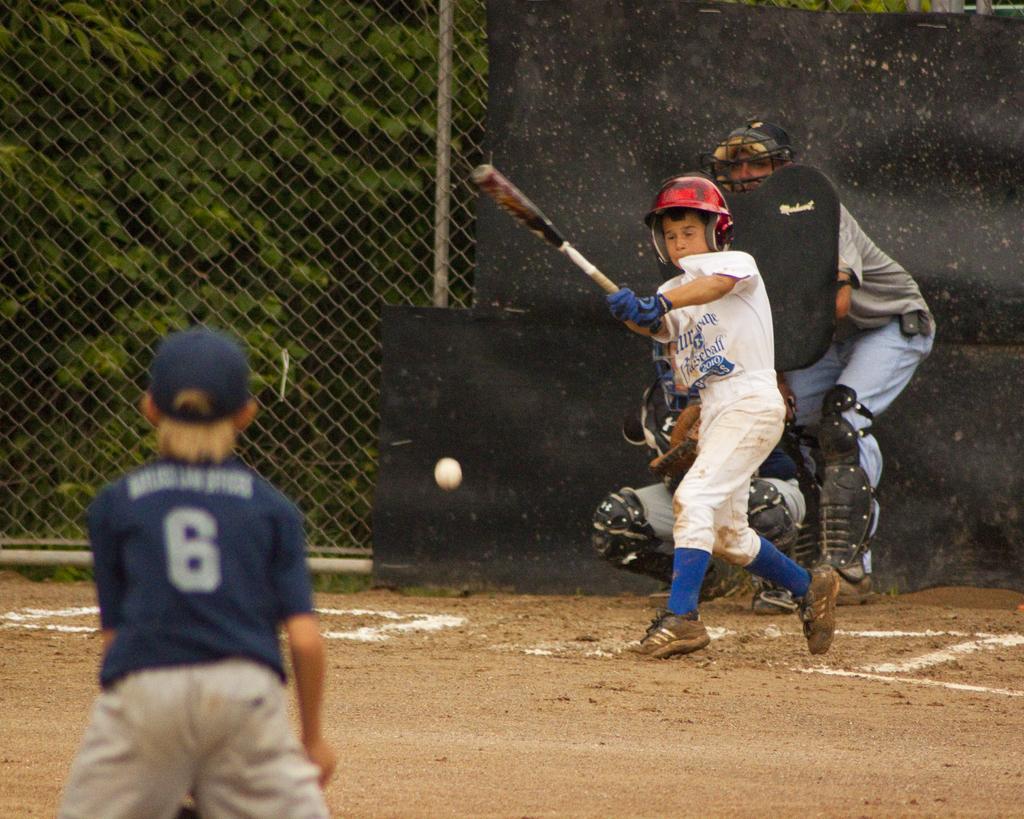Could you give a brief overview of what you see in this image? In this image I can see a person is holding the bat and wearing blue and white color dress and helmet. I can see two people, ball, net fencing and trees. 